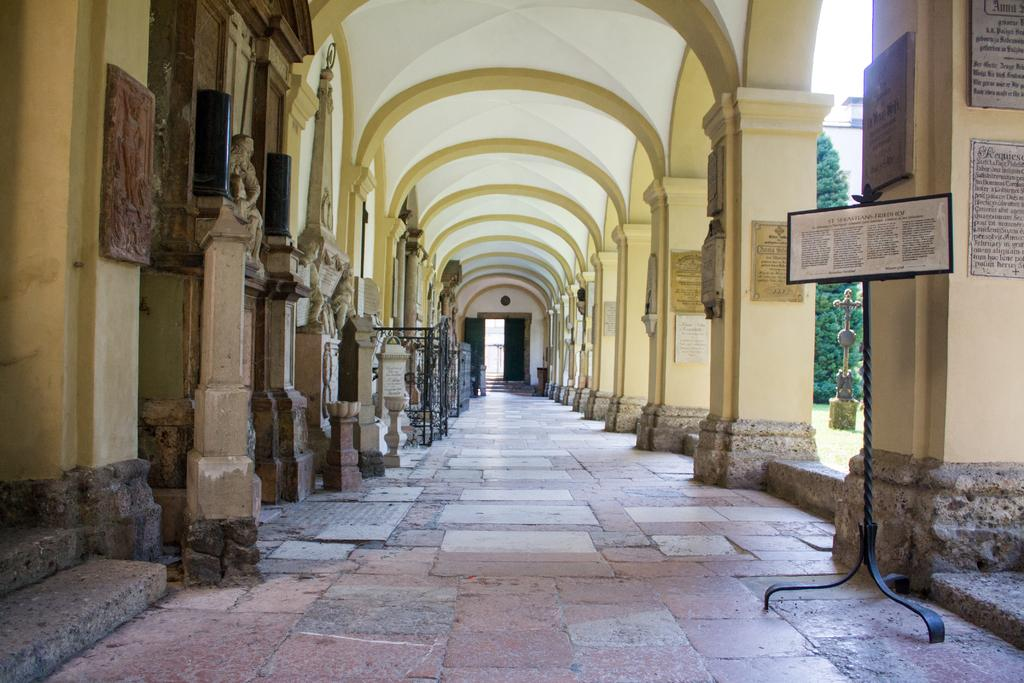What type of structures are on the floor in the image? There are stands on the floor in the image. What architectural elements can be seen in the image? There are pillars in the image. What type of signage or information is present in the image? There are boards in the image. What type of artistic or historical figures are depicted in the image? There are statues in the image. What part of the building can be seen in the image? The ceiling is visible in the image. What type of objects are present in the image? There are objects in the image. What type of natural element is visible in the background of the image? There is a tree in the background of the image. What type of religious symbol is visible in the background of the image? There is a cross in the background of the image. What type of toy can be seen playing with the tree in the image? There is no toy present in the image, and the tree is not interacting with any objects. What type of shock can be seen affecting the statues in the image? There is no shock present in the image, and the statues are not affected by any electrical or physical disturbances. 